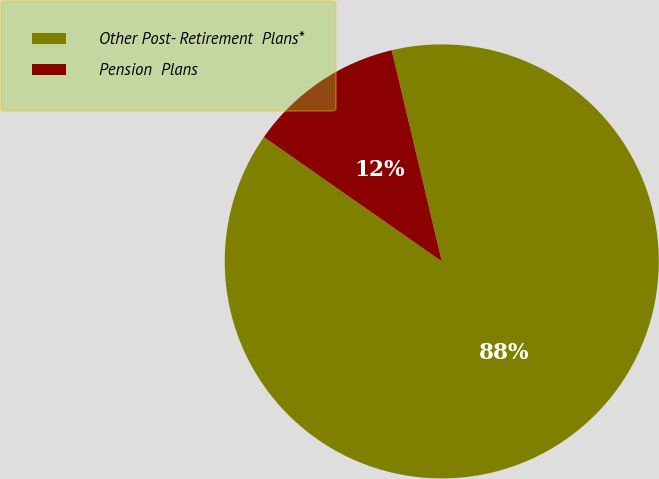<chart> <loc_0><loc_0><loc_500><loc_500><pie_chart><fcel>Other Post- Retirement  Plans*<fcel>Pension  Plans<nl><fcel>88.41%<fcel>11.59%<nl></chart> 